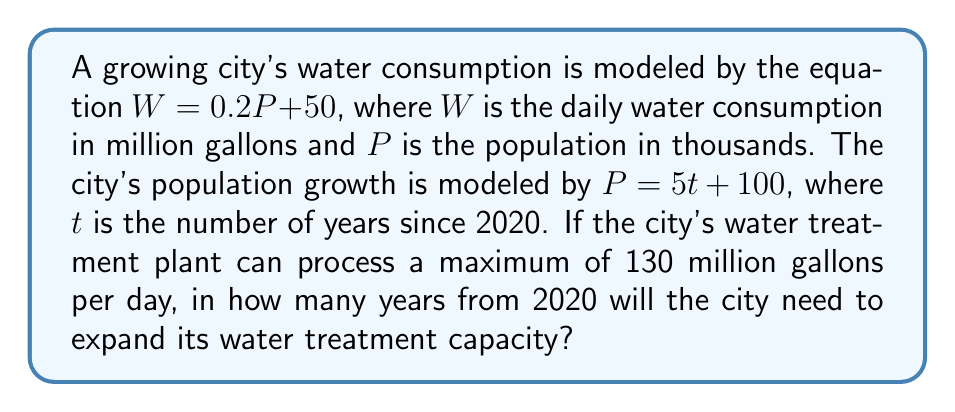Help me with this question. To solve this problem, we need to follow these steps:

1) First, we need to combine the two equations to express water consumption in terms of time:
   
   $W = 0.2P + 50$
   $P = 5t + 100$
   
   Substituting $P$ into the first equation:
   
   $W = 0.2(5t + 100) + 50$
   $W = t + 20 + 50$
   $W = t + 70$

2) Now we have water consumption as a function of time. We need to find when this will exceed the plant's capacity:

   $t + 70 = 130$

3) Solve for $t$:
   
   $t = 130 - 70 = 60$

4) This means that 60 years after 2020, the water consumption will reach the plant's maximum capacity.

This analysis provides valuable insight into the long-term impact of population growth on urban water infrastructure, a key concern in environmental history.
Answer: The city will need to expand its water treatment capacity in 60 years from 2020, which is in the year 2080. 